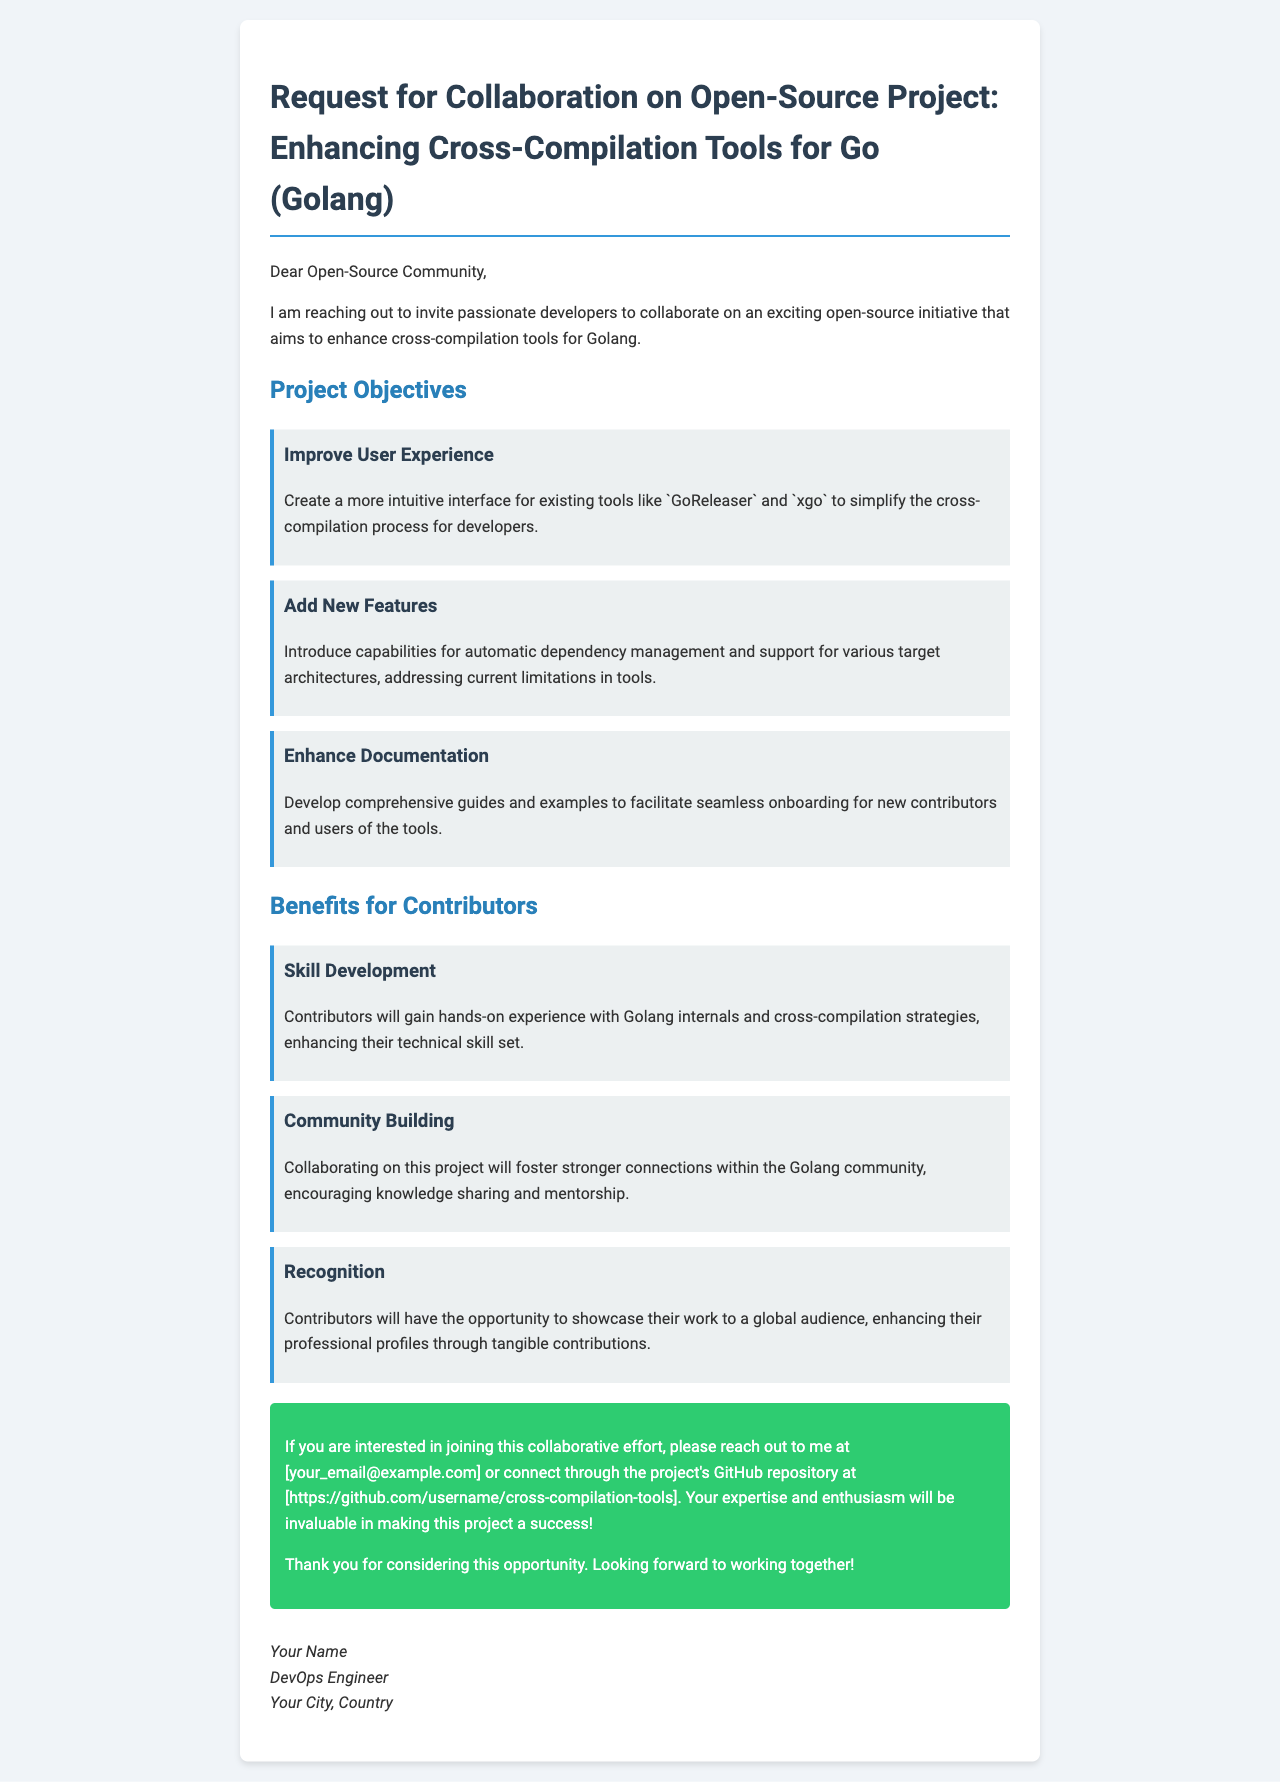What is the title of the project? The title of the project is specified in the opening line of the document, mentioning the main focus of the collaboration.
Answer: Enhancing Cross-Compilation Tools for Go (Golang) Who is the intended audience for the collaboration request? The intended audience is specified early in the document, addressing those who might be interested in contributing.
Answer: Open-Source Community What is one of the project objectives related to user interface? An objective is provided that specifically mentions improving usability for developers, focusing on the interaction with existing tools.
Answer: Create a more intuitive interface What is a benefit for contributors mentioned in the document? The document outlines various advantages for those who participate in the project, highlighting  one specific aspect related to skill growth.
Answer: Skill Development Where can contributors reach out if they are interested in the project? Contact points for potential collaborators are provided towards the end of the document, detailing how to connect for further involvement.
Answer: [your_email@example.com] How many project objectives are listed in the document? The document lists specific goals to achieve for the collaboration, which can be counted.
Answer: Three What is a highlighted feature under 'Add New Features'? The document specifies a particular functionality that will be introduced as part of the project scope, addressing current limitations.
Answer: Automatic dependency management What type of experience will contributors gain? The document specifically mentions the nature of the experience that participants will acquire through their involvement.
Answer: Hands-on experience with Golang internals Who signed the document? The document concludes with a sign-off section revealing the identity of the person behind the collaboration request.
Answer: Your Name 